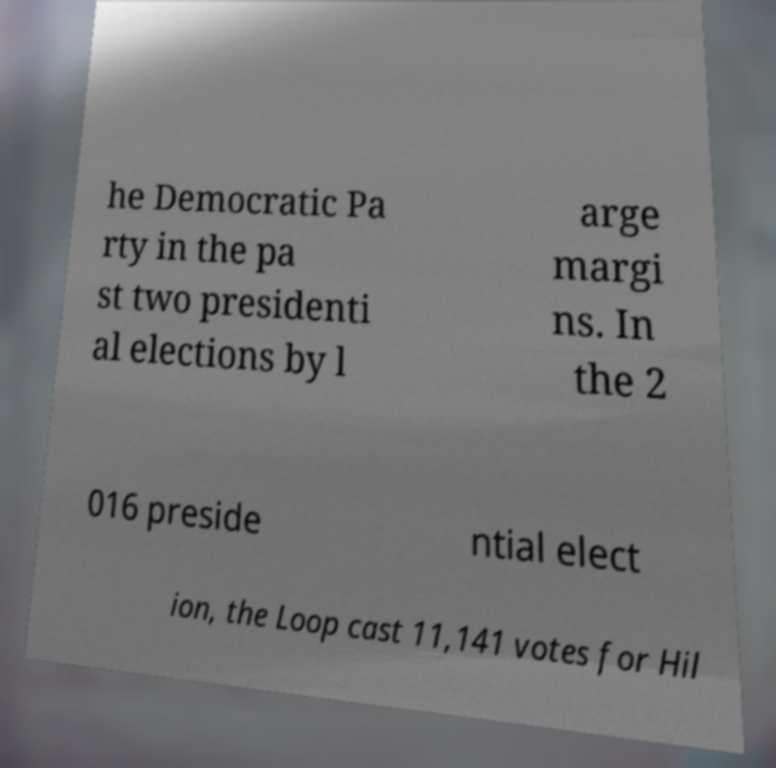Could you assist in decoding the text presented in this image and type it out clearly? he Democratic Pa rty in the pa st two presidenti al elections by l arge margi ns. In the 2 016 preside ntial elect ion, the Loop cast 11,141 votes for Hil 